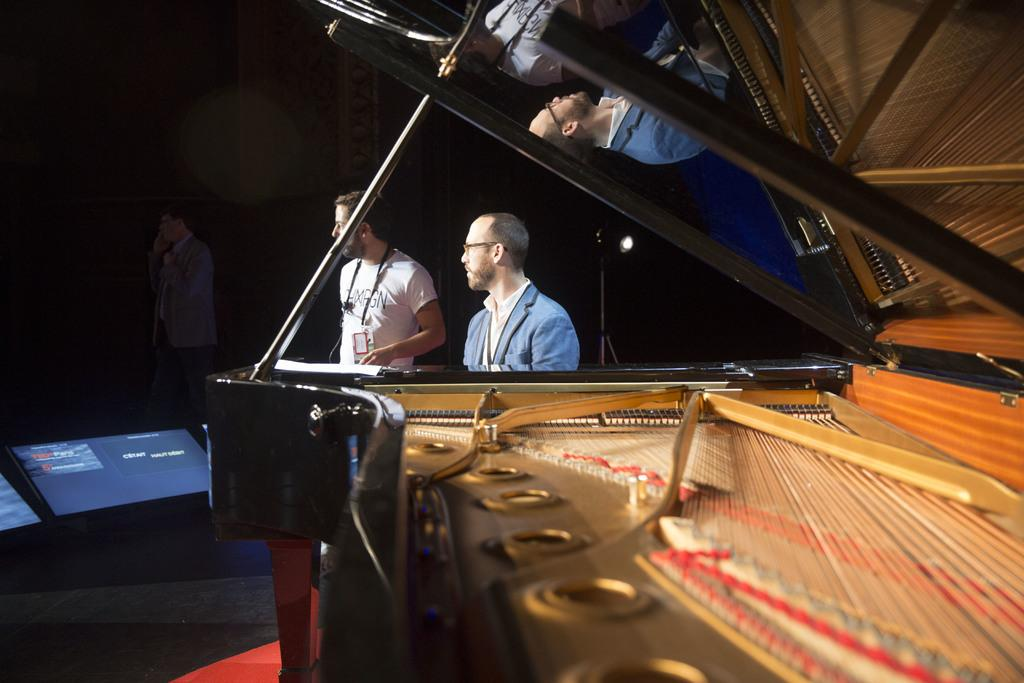How many people are in the image? There are three persons in the image. What is the main object in the image? There is a grand piano in the image. Can you describe the lighting setup in the image? There is a light with a stand in the image. What can be seen on the left side of the image? There are two screens on the floor on the left side of the image. How would you describe the overall lighting condition in the image? The background of the image is dark. What type of shirt is the creature wearing in the image? There is no creature present in the image, and therefore no shirt can be observed. 